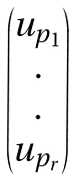<formula> <loc_0><loc_0><loc_500><loc_500>\begin{pmatrix} u _ { p _ { 1 } } \\ . \\ . \\ u _ { p _ { r } } \end{pmatrix}</formula> 